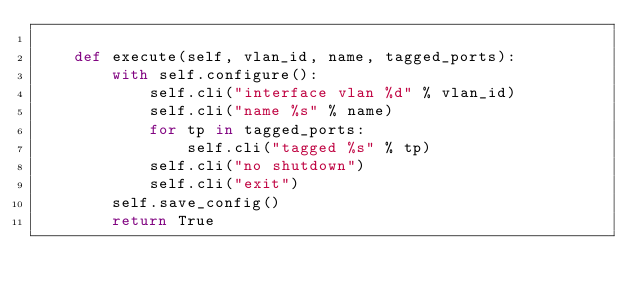Convert code to text. <code><loc_0><loc_0><loc_500><loc_500><_Python_>
    def execute(self, vlan_id, name, tagged_ports):
        with self.configure():
            self.cli("interface vlan %d" % vlan_id)
            self.cli("name %s" % name)
            for tp in tagged_ports:
                self.cli("tagged %s" % tp)
            self.cli("no shutdown")
            self.cli("exit")
        self.save_config()
        return True
</code> 